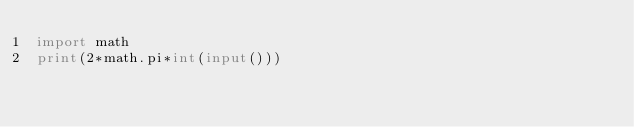Convert code to text. <code><loc_0><loc_0><loc_500><loc_500><_Python_>import math
print(2*math.pi*int(input()))</code> 